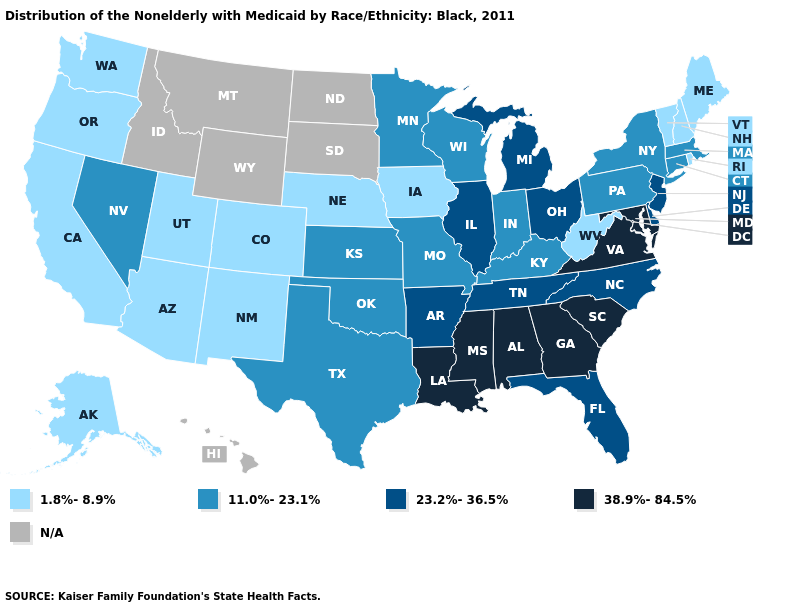What is the lowest value in the West?
Answer briefly. 1.8%-8.9%. Does Wisconsin have the lowest value in the USA?
Concise answer only. No. Name the states that have a value in the range 23.2%-36.5%?
Short answer required. Arkansas, Delaware, Florida, Illinois, Michigan, New Jersey, North Carolina, Ohio, Tennessee. What is the highest value in states that border Missouri?
Be succinct. 23.2%-36.5%. Which states have the highest value in the USA?
Answer briefly. Alabama, Georgia, Louisiana, Maryland, Mississippi, South Carolina, Virginia. How many symbols are there in the legend?
Short answer required. 5. What is the value of Ohio?
Give a very brief answer. 23.2%-36.5%. What is the value of North Dakota?
Keep it brief. N/A. Does New Jersey have the highest value in the Northeast?
Be succinct. Yes. What is the value of Illinois?
Concise answer only. 23.2%-36.5%. What is the value of Florida?
Answer briefly. 23.2%-36.5%. Does Pennsylvania have the highest value in the USA?
Keep it brief. No. Among the states that border Iowa , does Nebraska have the lowest value?
Be succinct. Yes. Which states have the highest value in the USA?
Write a very short answer. Alabama, Georgia, Louisiana, Maryland, Mississippi, South Carolina, Virginia. 